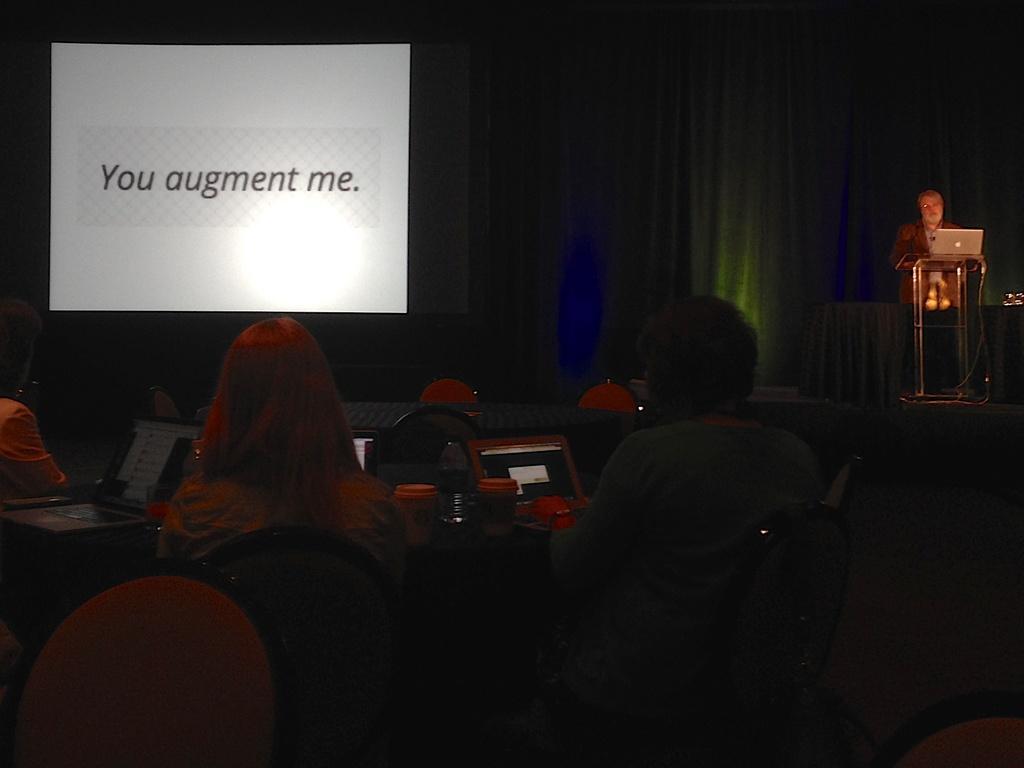Can you describe this image briefly? In the image there is a projector screen and it is displaying some statement and on the right side there is a man standing in front of a table, there is a laptop in front of him and there are a group of people sitting around the table and on the table there are laptops, bottles and other items. 